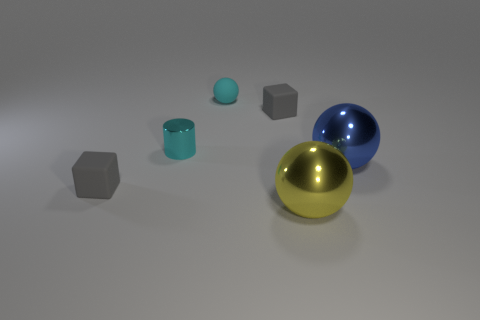Is the tiny gray block on the right side of the tiny cyan matte thing made of the same material as the block that is left of the cyan ball?
Make the answer very short. Yes. There is a tiny cyan object that is made of the same material as the blue object; what is its shape?
Your answer should be very brief. Cylinder. Is there anything else of the same color as the tiny shiny cylinder?
Your answer should be compact. Yes. What number of big yellow metallic things are there?
Make the answer very short. 1. There is a small object that is behind the small gray rubber thing behind the cyan metal object; what is its material?
Make the answer very short. Rubber. There is a tiny matte cube that is left of the tiny gray thing on the right side of the cube in front of the blue metallic object; what color is it?
Provide a succinct answer. Gray. Do the metallic cylinder and the small rubber ball have the same color?
Ensure brevity in your answer.  Yes. How many metal spheres are the same size as the blue object?
Your answer should be very brief. 1. Is the number of yellow metallic balls that are behind the yellow object greater than the number of small gray objects that are to the right of the blue metal thing?
Your answer should be very brief. No. The small rubber thing that is in front of the metallic object that is on the left side of the yellow metallic thing is what color?
Provide a short and direct response. Gray. 